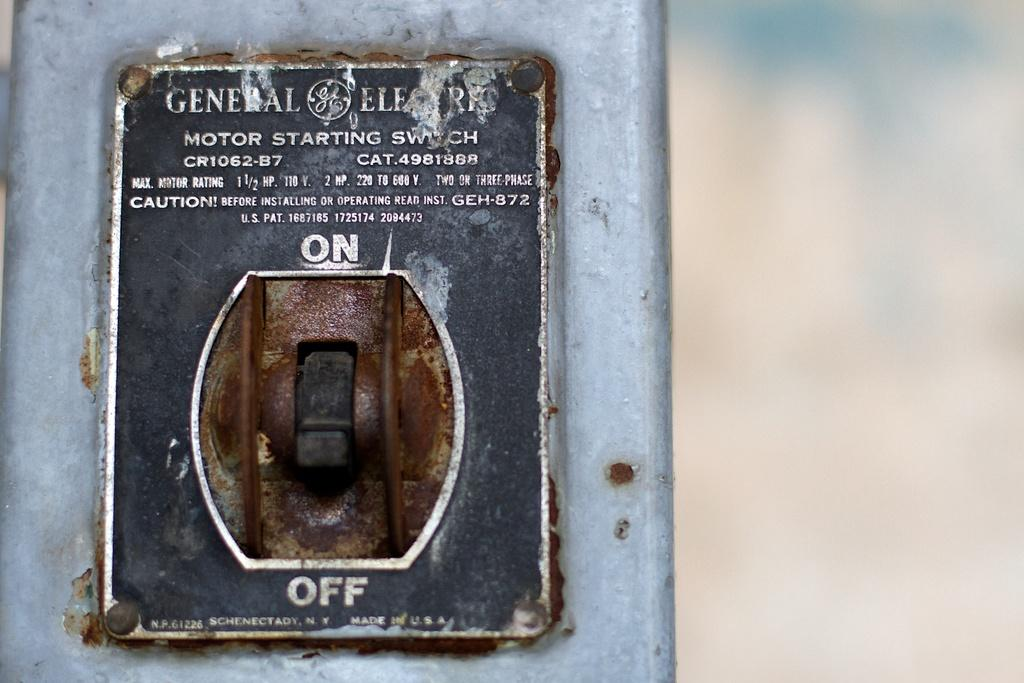<image>
Present a compact description of the photo's key features. Well this very old switch pictured has been turned off. 